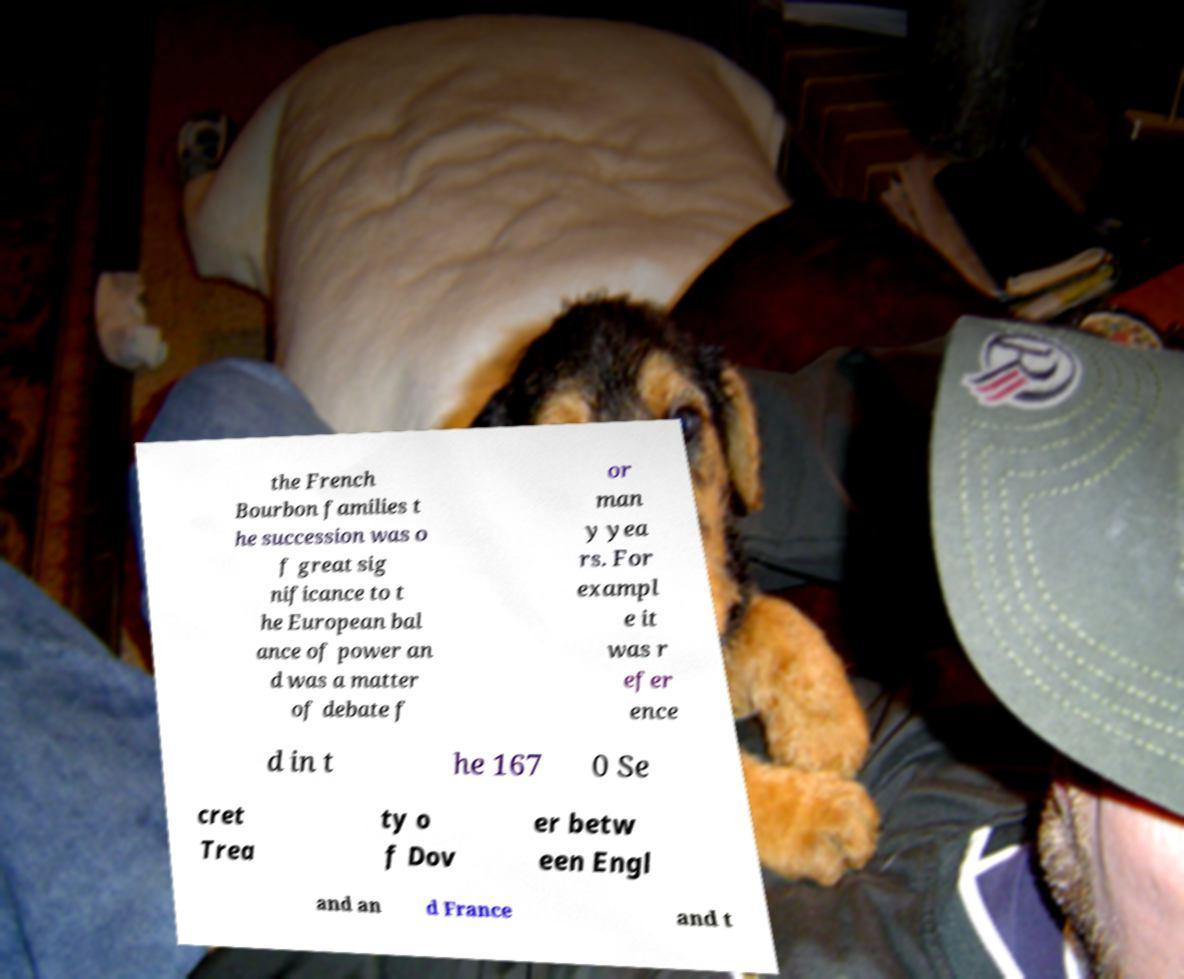There's text embedded in this image that I need extracted. Can you transcribe it verbatim? the French Bourbon families t he succession was o f great sig nificance to t he European bal ance of power an d was a matter of debate f or man y yea rs. For exampl e it was r efer ence d in t he 167 0 Se cret Trea ty o f Dov er betw een Engl and an d France and t 